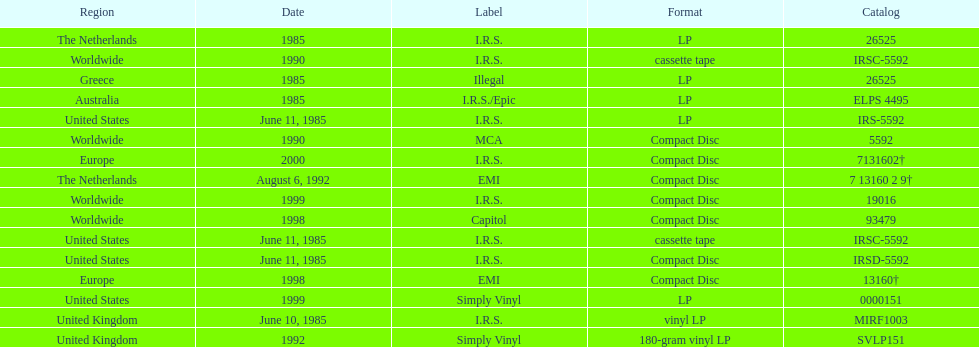Write the full table. {'header': ['Region', 'Date', 'Label', 'Format', 'Catalog'], 'rows': [['The Netherlands', '1985', 'I.R.S.', 'LP', '26525'], ['Worldwide', '1990', 'I.R.S.', 'cassette tape', 'IRSC-5592'], ['Greece', '1985', 'Illegal', 'LP', '26525'], ['Australia', '1985', 'I.R.S./Epic', 'LP', 'ELPS 4495'], ['United States', 'June 11, 1985', 'I.R.S.', 'LP', 'IRS-5592'], ['Worldwide', '1990', 'MCA', 'Compact Disc', '5592'], ['Europe', '2000', 'I.R.S.', 'Compact Disc', '7131602†'], ['The Netherlands', 'August 6, 1992', 'EMI', 'Compact Disc', '7 13160 2 9†'], ['Worldwide', '1999', 'I.R.S.', 'Compact Disc', '19016'], ['Worldwide', '1998', 'Capitol', 'Compact Disc', '93479'], ['United States', 'June 11, 1985', 'I.R.S.', 'cassette tape', 'IRSC-5592'], ['United States', 'June 11, 1985', 'I.R.S.', 'Compact Disc', 'IRSD-5592'], ['Europe', '1998', 'EMI', 'Compact Disc', '13160†'], ['United States', '1999', 'Simply Vinyl', 'LP', '0000151'], ['United Kingdom', 'June 10, 1985', 'I.R.S.', 'vinyl LP', 'MIRF1003'], ['United Kingdom', '1992', 'Simply Vinyl', '180-gram vinyl LP', 'SVLP151']]} What is the greatest consecutive amount of releases in lp format? 3. 